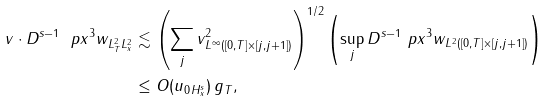<formula> <loc_0><loc_0><loc_500><loc_500>\| v \cdot D ^ { s - 1 } \ p x ^ { 3 } w \| _ { L ^ { 2 } _ { T } L ^ { 2 } _ { x } } & \lesssim \left ( \sum _ { j } \| v \| ^ { 2 } _ { L ^ { \infty } ( [ 0 , T ] \times [ j , j + 1 ] ) } \right ) ^ { 1 / 2 } \left ( \sup _ { j } \| D ^ { s - 1 } \ p x ^ { 3 } w \| _ { L ^ { 2 } ( [ 0 , T ] \times [ j , j + 1 ] ) } \right ) \\ & \leq O ( \| u _ { 0 } \| _ { H ^ { s } _ { x } } ) \, g _ { T } ,</formula> 